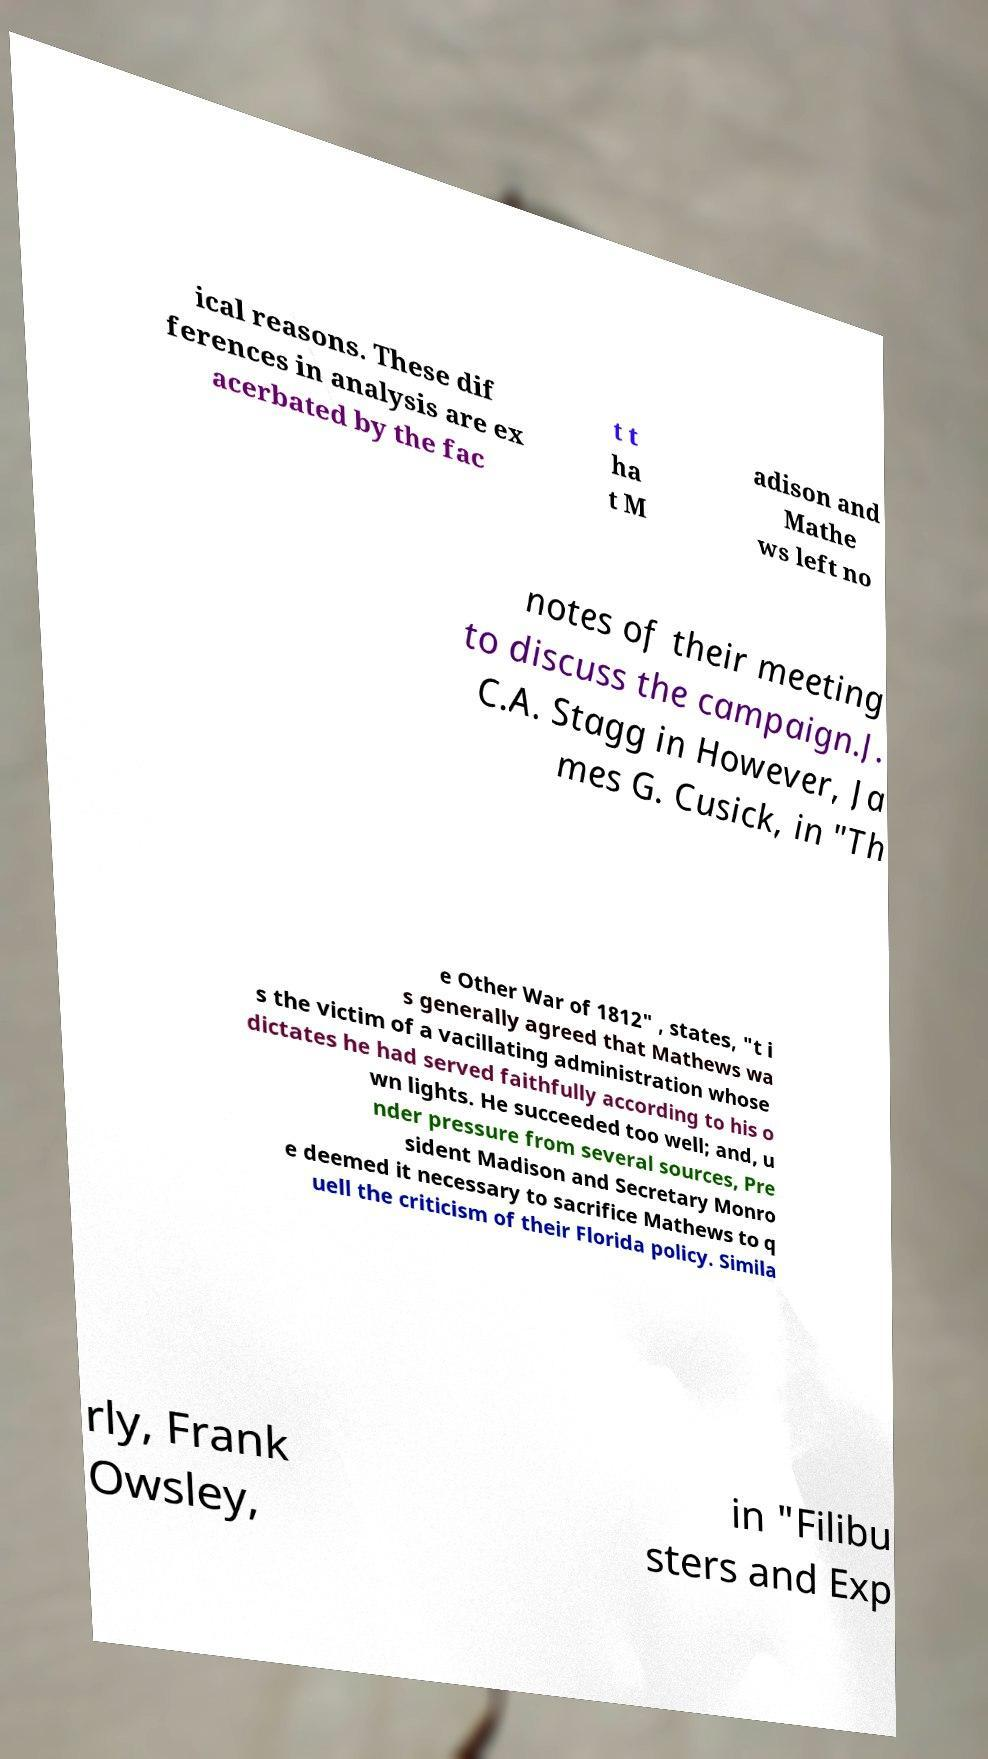Can you read and provide the text displayed in the image?This photo seems to have some interesting text. Can you extract and type it out for me? ical reasons. These dif ferences in analysis are ex acerbated by the fac t t ha t M adison and Mathe ws left no notes of their meeting to discuss the campaign.J. C.A. Stagg in However, Ja mes G. Cusick, in "Th e Other War of 1812" , states, "t i s generally agreed that Mathews wa s the victim of a vacillating administration whose dictates he had served faithfully according to his o wn lights. He succeeded too well; and, u nder pressure from several sources, Pre sident Madison and Secretary Monro e deemed it necessary to sacrifice Mathews to q uell the criticism of their Florida policy. Simila rly, Frank Owsley, in "Filibu sters and Exp 